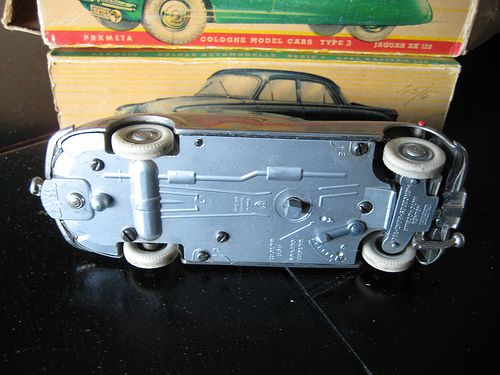<image>
Is there a car on the wheel? No. The car is not positioned on the wheel. They may be near each other, but the car is not supported by or resting on top of the wheel. 